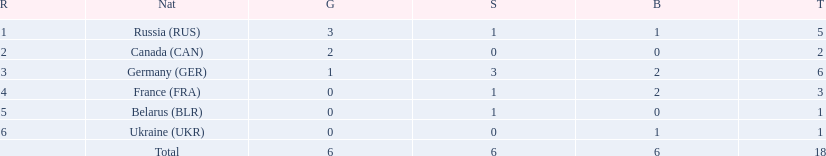Which nations participated? Russia (RUS), Canada (CAN), Germany (GER), France (FRA), Belarus (BLR), Ukraine (UKR). And how many gold medals did they win? 3, 2, 1, 0, 0, 0. What about silver medals? 1, 0, 3, 1, 1, 0. And bronze? 1, 0, 2, 2, 0, 1. Which nation only won gold medals? Canada (CAN). 